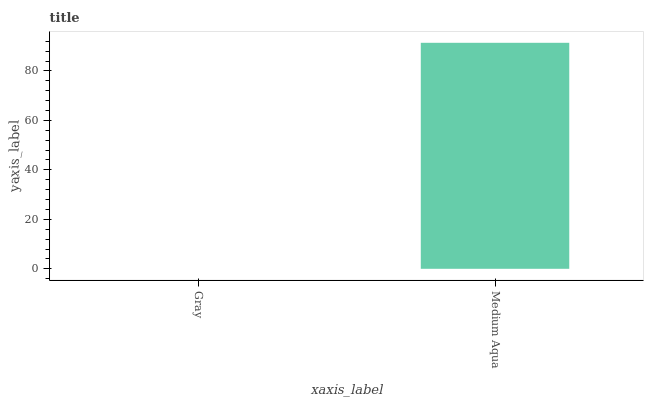Is Gray the minimum?
Answer yes or no. Yes. Is Medium Aqua the maximum?
Answer yes or no. Yes. Is Medium Aqua the minimum?
Answer yes or no. No. Is Medium Aqua greater than Gray?
Answer yes or no. Yes. Is Gray less than Medium Aqua?
Answer yes or no. Yes. Is Gray greater than Medium Aqua?
Answer yes or no. No. Is Medium Aqua less than Gray?
Answer yes or no. No. Is Medium Aqua the high median?
Answer yes or no. Yes. Is Gray the low median?
Answer yes or no. Yes. Is Gray the high median?
Answer yes or no. No. Is Medium Aqua the low median?
Answer yes or no. No. 